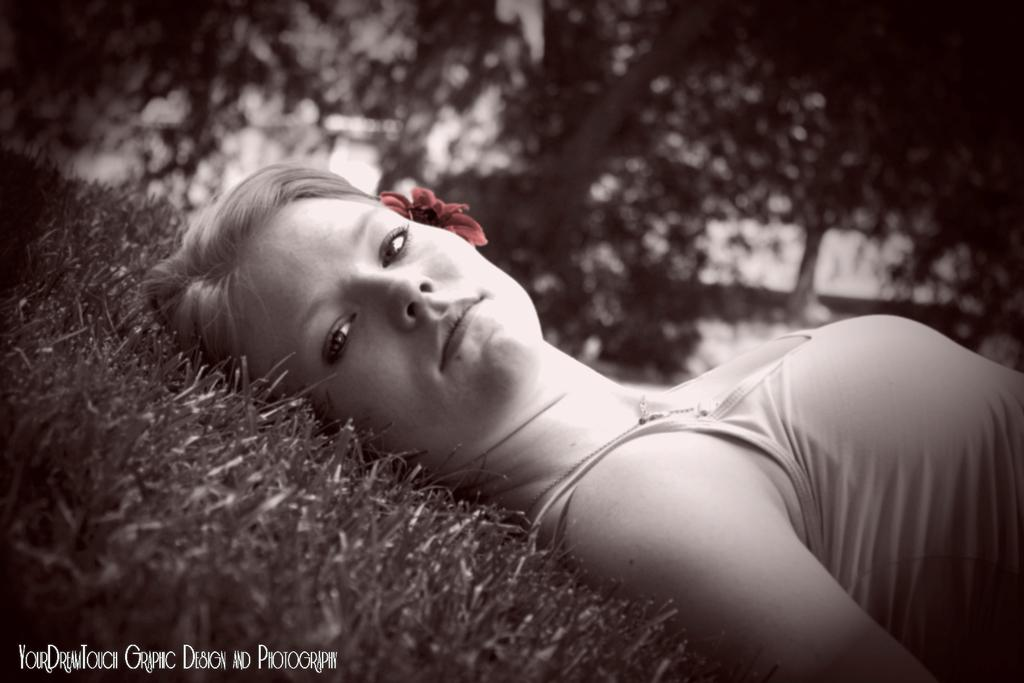What is the color scheme of the image? The image is in black and white. What is the woman in the image doing? The woman is lying on the ground in the image. What can be seen in the background of the image? There are trees and grass visible in the background of the image. What sign is the woman holding in the image? There is no sign present in the image; the woman is lying on the ground. How does the woman use her brain in the image? The image does not show the woman using her brain or any cognitive activity. 